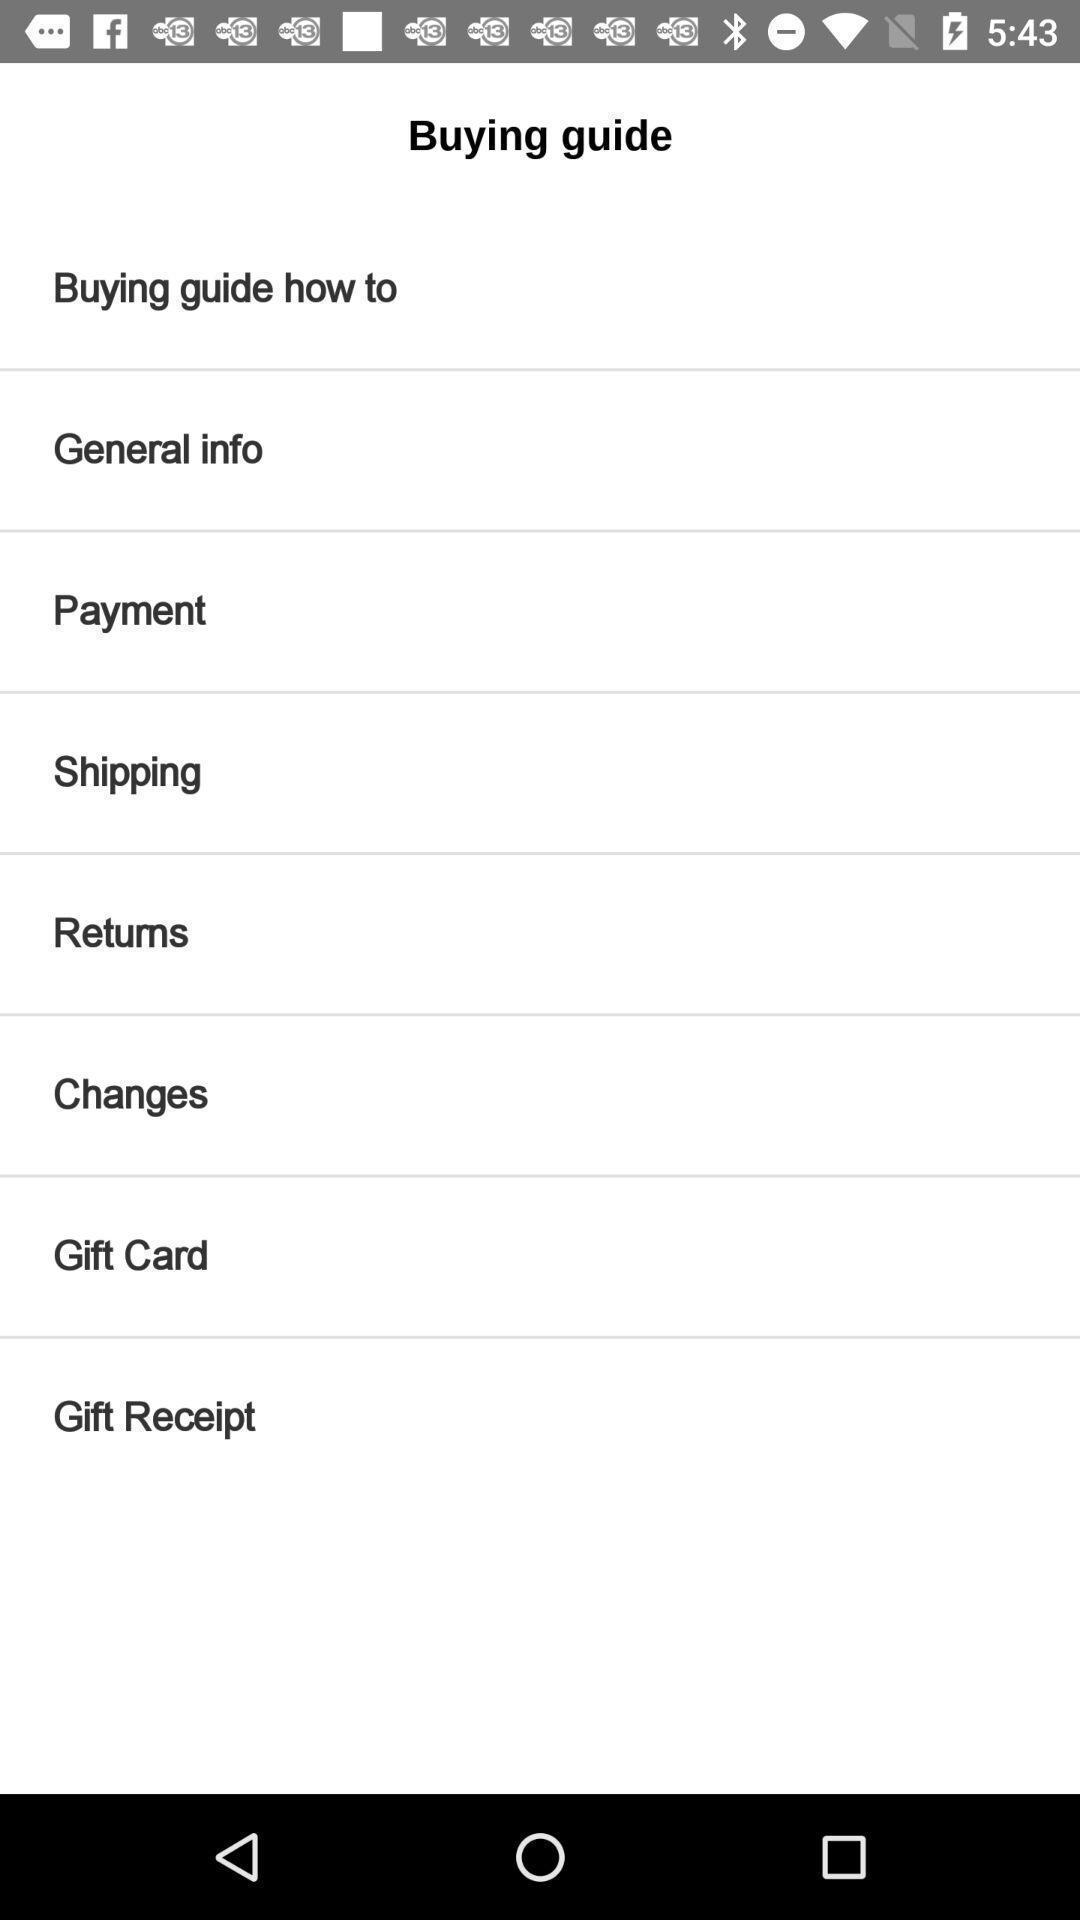What is the overall content of this screenshot? Screen shows a buying guide. 